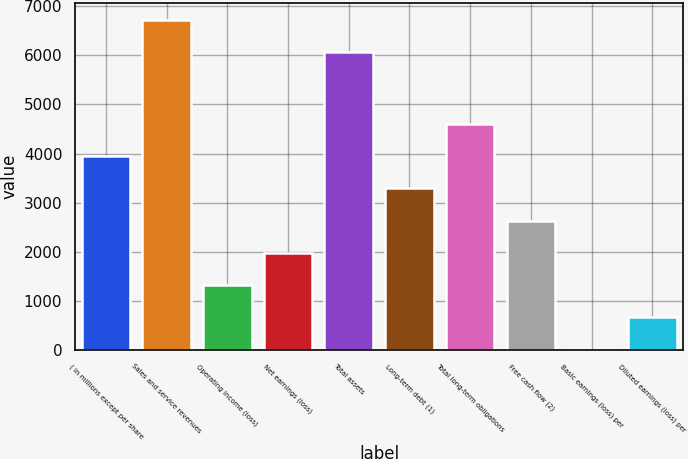Convert chart. <chart><loc_0><loc_0><loc_500><loc_500><bar_chart><fcel>( in millions except per share<fcel>Sales and service revenues<fcel>Operating income (loss)<fcel>Net earnings (loss)<fcel>Total assets<fcel>Long-term debt (1)<fcel>Total long-term obligations<fcel>Free cash flow (2)<fcel>Basic earnings (loss) per<fcel>Diluted earnings (loss) per<nl><fcel>3945.83<fcel>6726.3<fcel>1316.64<fcel>1973.94<fcel>6069<fcel>3288.53<fcel>4603.12<fcel>2631.24<fcel>2.05<fcel>659.35<nl></chart> 